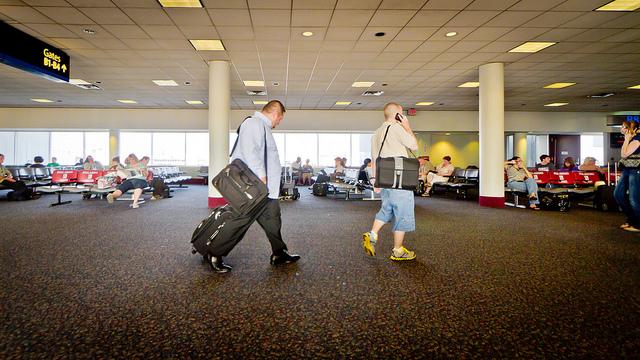Does this look like an airport terminal?
Write a very short answer. Yes. What do the men in the foreground have?
Quick response, please. Suitcases. Does he have waterproof boots on?
Concise answer only. No. Which light is not on?
Write a very short answer. None. 